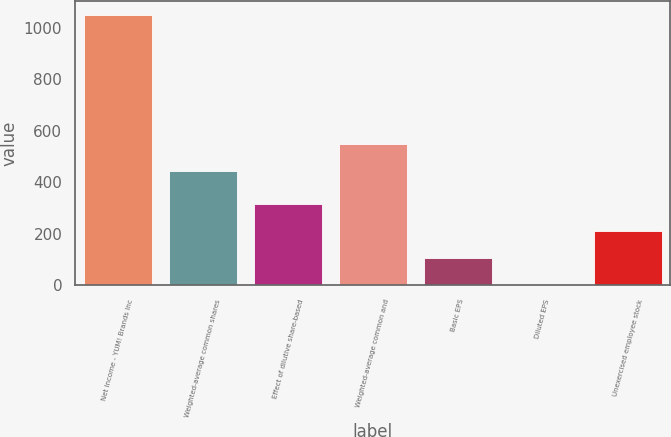Convert chart. <chart><loc_0><loc_0><loc_500><loc_500><bar_chart><fcel>Net Income - YUM! Brands Inc<fcel>Weighted-average common shares<fcel>Effect of dilutive share-based<fcel>Weighted-average common and<fcel>Basic EPS<fcel>Diluted EPS<fcel>Unexercised employee stock<nl><fcel>1051<fcel>444<fcel>316.93<fcel>548.87<fcel>107.19<fcel>2.32<fcel>212.06<nl></chart> 